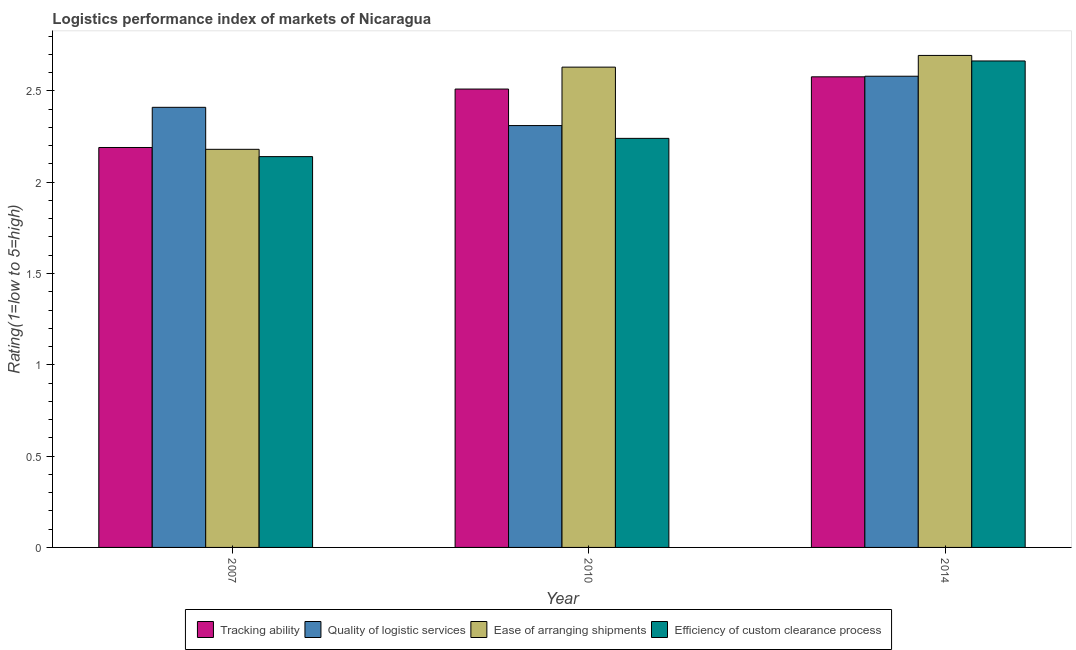How many different coloured bars are there?
Your answer should be very brief. 4. How many groups of bars are there?
Provide a succinct answer. 3. Are the number of bars per tick equal to the number of legend labels?
Keep it short and to the point. Yes. How many bars are there on the 3rd tick from the left?
Provide a short and direct response. 4. In how many cases, is the number of bars for a given year not equal to the number of legend labels?
Make the answer very short. 0. What is the lpi rating of efficiency of custom clearance process in 2014?
Offer a terse response. 2.66. Across all years, what is the maximum lpi rating of tracking ability?
Your answer should be very brief. 2.58. Across all years, what is the minimum lpi rating of tracking ability?
Your answer should be compact. 2.19. In which year was the lpi rating of quality of logistic services minimum?
Your answer should be compact. 2010. What is the total lpi rating of tracking ability in the graph?
Make the answer very short. 7.28. What is the difference between the lpi rating of tracking ability in 2007 and that in 2010?
Provide a short and direct response. -0.32. What is the difference between the lpi rating of ease of arranging shipments in 2010 and the lpi rating of quality of logistic services in 2007?
Your answer should be compact. 0.45. What is the average lpi rating of ease of arranging shipments per year?
Your answer should be compact. 2.5. In the year 2014, what is the difference between the lpi rating of ease of arranging shipments and lpi rating of efficiency of custom clearance process?
Give a very brief answer. 0. What is the ratio of the lpi rating of quality of logistic services in 2007 to that in 2010?
Ensure brevity in your answer.  1.04. Is the difference between the lpi rating of efficiency of custom clearance process in 2007 and 2010 greater than the difference between the lpi rating of ease of arranging shipments in 2007 and 2010?
Give a very brief answer. No. What is the difference between the highest and the second highest lpi rating of quality of logistic services?
Offer a terse response. 0.17. What is the difference between the highest and the lowest lpi rating of ease of arranging shipments?
Your answer should be compact. 0.51. In how many years, is the lpi rating of efficiency of custom clearance process greater than the average lpi rating of efficiency of custom clearance process taken over all years?
Offer a very short reply. 1. Is it the case that in every year, the sum of the lpi rating of tracking ability and lpi rating of quality of logistic services is greater than the sum of lpi rating of efficiency of custom clearance process and lpi rating of ease of arranging shipments?
Make the answer very short. No. What does the 2nd bar from the left in 2014 represents?
Provide a short and direct response. Quality of logistic services. What does the 4th bar from the right in 2007 represents?
Offer a very short reply. Tracking ability. What is the difference between two consecutive major ticks on the Y-axis?
Your response must be concise. 0.5. Does the graph contain grids?
Your answer should be compact. No. How many legend labels are there?
Ensure brevity in your answer.  4. What is the title of the graph?
Offer a very short reply. Logistics performance index of markets of Nicaragua. What is the label or title of the Y-axis?
Offer a terse response. Rating(1=low to 5=high). What is the Rating(1=low to 5=high) in Tracking ability in 2007?
Your answer should be compact. 2.19. What is the Rating(1=low to 5=high) of Quality of logistic services in 2007?
Provide a short and direct response. 2.41. What is the Rating(1=low to 5=high) in Ease of arranging shipments in 2007?
Offer a terse response. 2.18. What is the Rating(1=low to 5=high) in Efficiency of custom clearance process in 2007?
Give a very brief answer. 2.14. What is the Rating(1=low to 5=high) in Tracking ability in 2010?
Provide a short and direct response. 2.51. What is the Rating(1=low to 5=high) in Quality of logistic services in 2010?
Your response must be concise. 2.31. What is the Rating(1=low to 5=high) of Ease of arranging shipments in 2010?
Provide a short and direct response. 2.63. What is the Rating(1=low to 5=high) in Efficiency of custom clearance process in 2010?
Offer a terse response. 2.24. What is the Rating(1=low to 5=high) of Tracking ability in 2014?
Ensure brevity in your answer.  2.58. What is the Rating(1=low to 5=high) in Quality of logistic services in 2014?
Provide a succinct answer. 2.58. What is the Rating(1=low to 5=high) in Ease of arranging shipments in 2014?
Keep it short and to the point. 2.69. What is the Rating(1=low to 5=high) of Efficiency of custom clearance process in 2014?
Offer a very short reply. 2.66. Across all years, what is the maximum Rating(1=low to 5=high) in Tracking ability?
Make the answer very short. 2.58. Across all years, what is the maximum Rating(1=low to 5=high) of Quality of logistic services?
Your response must be concise. 2.58. Across all years, what is the maximum Rating(1=low to 5=high) in Ease of arranging shipments?
Provide a succinct answer. 2.69. Across all years, what is the maximum Rating(1=low to 5=high) in Efficiency of custom clearance process?
Provide a succinct answer. 2.66. Across all years, what is the minimum Rating(1=low to 5=high) in Tracking ability?
Make the answer very short. 2.19. Across all years, what is the minimum Rating(1=low to 5=high) of Quality of logistic services?
Offer a terse response. 2.31. Across all years, what is the minimum Rating(1=low to 5=high) in Ease of arranging shipments?
Make the answer very short. 2.18. Across all years, what is the minimum Rating(1=low to 5=high) in Efficiency of custom clearance process?
Your answer should be compact. 2.14. What is the total Rating(1=low to 5=high) in Tracking ability in the graph?
Offer a very short reply. 7.28. What is the total Rating(1=low to 5=high) of Quality of logistic services in the graph?
Provide a short and direct response. 7.3. What is the total Rating(1=low to 5=high) of Ease of arranging shipments in the graph?
Provide a short and direct response. 7.5. What is the total Rating(1=low to 5=high) of Efficiency of custom clearance process in the graph?
Provide a short and direct response. 7.04. What is the difference between the Rating(1=low to 5=high) of Tracking ability in 2007 and that in 2010?
Provide a succinct answer. -0.32. What is the difference between the Rating(1=low to 5=high) in Quality of logistic services in 2007 and that in 2010?
Your response must be concise. 0.1. What is the difference between the Rating(1=low to 5=high) of Ease of arranging shipments in 2007 and that in 2010?
Make the answer very short. -0.45. What is the difference between the Rating(1=low to 5=high) in Efficiency of custom clearance process in 2007 and that in 2010?
Make the answer very short. -0.1. What is the difference between the Rating(1=low to 5=high) in Tracking ability in 2007 and that in 2014?
Your response must be concise. -0.39. What is the difference between the Rating(1=low to 5=high) in Quality of logistic services in 2007 and that in 2014?
Provide a succinct answer. -0.17. What is the difference between the Rating(1=low to 5=high) in Ease of arranging shipments in 2007 and that in 2014?
Offer a very short reply. -0.51. What is the difference between the Rating(1=low to 5=high) of Efficiency of custom clearance process in 2007 and that in 2014?
Offer a terse response. -0.52. What is the difference between the Rating(1=low to 5=high) in Tracking ability in 2010 and that in 2014?
Give a very brief answer. -0.07. What is the difference between the Rating(1=low to 5=high) of Quality of logistic services in 2010 and that in 2014?
Offer a terse response. -0.27. What is the difference between the Rating(1=low to 5=high) in Ease of arranging shipments in 2010 and that in 2014?
Make the answer very short. -0.06. What is the difference between the Rating(1=low to 5=high) of Efficiency of custom clearance process in 2010 and that in 2014?
Make the answer very short. -0.42. What is the difference between the Rating(1=low to 5=high) in Tracking ability in 2007 and the Rating(1=low to 5=high) in Quality of logistic services in 2010?
Offer a very short reply. -0.12. What is the difference between the Rating(1=low to 5=high) of Tracking ability in 2007 and the Rating(1=low to 5=high) of Ease of arranging shipments in 2010?
Your answer should be compact. -0.44. What is the difference between the Rating(1=low to 5=high) of Quality of logistic services in 2007 and the Rating(1=low to 5=high) of Ease of arranging shipments in 2010?
Your answer should be compact. -0.22. What is the difference between the Rating(1=low to 5=high) of Quality of logistic services in 2007 and the Rating(1=low to 5=high) of Efficiency of custom clearance process in 2010?
Your answer should be compact. 0.17. What is the difference between the Rating(1=low to 5=high) in Ease of arranging shipments in 2007 and the Rating(1=low to 5=high) in Efficiency of custom clearance process in 2010?
Your answer should be very brief. -0.06. What is the difference between the Rating(1=low to 5=high) of Tracking ability in 2007 and the Rating(1=low to 5=high) of Quality of logistic services in 2014?
Your answer should be compact. -0.39. What is the difference between the Rating(1=low to 5=high) of Tracking ability in 2007 and the Rating(1=low to 5=high) of Ease of arranging shipments in 2014?
Your response must be concise. -0.5. What is the difference between the Rating(1=low to 5=high) in Tracking ability in 2007 and the Rating(1=low to 5=high) in Efficiency of custom clearance process in 2014?
Make the answer very short. -0.47. What is the difference between the Rating(1=low to 5=high) of Quality of logistic services in 2007 and the Rating(1=low to 5=high) of Ease of arranging shipments in 2014?
Offer a very short reply. -0.28. What is the difference between the Rating(1=low to 5=high) in Quality of logistic services in 2007 and the Rating(1=low to 5=high) in Efficiency of custom clearance process in 2014?
Provide a succinct answer. -0.25. What is the difference between the Rating(1=low to 5=high) in Ease of arranging shipments in 2007 and the Rating(1=low to 5=high) in Efficiency of custom clearance process in 2014?
Ensure brevity in your answer.  -0.48. What is the difference between the Rating(1=low to 5=high) of Tracking ability in 2010 and the Rating(1=low to 5=high) of Quality of logistic services in 2014?
Offer a terse response. -0.07. What is the difference between the Rating(1=low to 5=high) of Tracking ability in 2010 and the Rating(1=low to 5=high) of Ease of arranging shipments in 2014?
Ensure brevity in your answer.  -0.18. What is the difference between the Rating(1=low to 5=high) in Tracking ability in 2010 and the Rating(1=low to 5=high) in Efficiency of custom clearance process in 2014?
Your response must be concise. -0.15. What is the difference between the Rating(1=low to 5=high) in Quality of logistic services in 2010 and the Rating(1=low to 5=high) in Ease of arranging shipments in 2014?
Offer a very short reply. -0.38. What is the difference between the Rating(1=low to 5=high) of Quality of logistic services in 2010 and the Rating(1=low to 5=high) of Efficiency of custom clearance process in 2014?
Offer a very short reply. -0.35. What is the difference between the Rating(1=low to 5=high) in Ease of arranging shipments in 2010 and the Rating(1=low to 5=high) in Efficiency of custom clearance process in 2014?
Your answer should be very brief. -0.03. What is the average Rating(1=low to 5=high) in Tracking ability per year?
Keep it short and to the point. 2.43. What is the average Rating(1=low to 5=high) in Quality of logistic services per year?
Provide a succinct answer. 2.43. What is the average Rating(1=low to 5=high) in Ease of arranging shipments per year?
Your answer should be compact. 2.5. What is the average Rating(1=low to 5=high) in Efficiency of custom clearance process per year?
Provide a short and direct response. 2.35. In the year 2007, what is the difference between the Rating(1=low to 5=high) of Tracking ability and Rating(1=low to 5=high) of Quality of logistic services?
Your answer should be very brief. -0.22. In the year 2007, what is the difference between the Rating(1=low to 5=high) in Quality of logistic services and Rating(1=low to 5=high) in Ease of arranging shipments?
Keep it short and to the point. 0.23. In the year 2007, what is the difference between the Rating(1=low to 5=high) in Quality of logistic services and Rating(1=low to 5=high) in Efficiency of custom clearance process?
Make the answer very short. 0.27. In the year 2007, what is the difference between the Rating(1=low to 5=high) of Ease of arranging shipments and Rating(1=low to 5=high) of Efficiency of custom clearance process?
Make the answer very short. 0.04. In the year 2010, what is the difference between the Rating(1=low to 5=high) in Tracking ability and Rating(1=low to 5=high) in Quality of logistic services?
Give a very brief answer. 0.2. In the year 2010, what is the difference between the Rating(1=low to 5=high) in Tracking ability and Rating(1=low to 5=high) in Ease of arranging shipments?
Offer a very short reply. -0.12. In the year 2010, what is the difference between the Rating(1=low to 5=high) in Tracking ability and Rating(1=low to 5=high) in Efficiency of custom clearance process?
Provide a succinct answer. 0.27. In the year 2010, what is the difference between the Rating(1=low to 5=high) in Quality of logistic services and Rating(1=low to 5=high) in Ease of arranging shipments?
Offer a very short reply. -0.32. In the year 2010, what is the difference between the Rating(1=low to 5=high) in Quality of logistic services and Rating(1=low to 5=high) in Efficiency of custom clearance process?
Keep it short and to the point. 0.07. In the year 2010, what is the difference between the Rating(1=low to 5=high) in Ease of arranging shipments and Rating(1=low to 5=high) in Efficiency of custom clearance process?
Give a very brief answer. 0.39. In the year 2014, what is the difference between the Rating(1=low to 5=high) of Tracking ability and Rating(1=low to 5=high) of Quality of logistic services?
Give a very brief answer. -0. In the year 2014, what is the difference between the Rating(1=low to 5=high) in Tracking ability and Rating(1=low to 5=high) in Ease of arranging shipments?
Provide a short and direct response. -0.12. In the year 2014, what is the difference between the Rating(1=low to 5=high) of Tracking ability and Rating(1=low to 5=high) of Efficiency of custom clearance process?
Ensure brevity in your answer.  -0.09. In the year 2014, what is the difference between the Rating(1=low to 5=high) in Quality of logistic services and Rating(1=low to 5=high) in Ease of arranging shipments?
Keep it short and to the point. -0.11. In the year 2014, what is the difference between the Rating(1=low to 5=high) in Quality of logistic services and Rating(1=low to 5=high) in Efficiency of custom clearance process?
Give a very brief answer. -0.08. In the year 2014, what is the difference between the Rating(1=low to 5=high) in Ease of arranging shipments and Rating(1=low to 5=high) in Efficiency of custom clearance process?
Offer a very short reply. 0.03. What is the ratio of the Rating(1=low to 5=high) of Tracking ability in 2007 to that in 2010?
Provide a succinct answer. 0.87. What is the ratio of the Rating(1=low to 5=high) of Quality of logistic services in 2007 to that in 2010?
Your answer should be very brief. 1.04. What is the ratio of the Rating(1=low to 5=high) in Ease of arranging shipments in 2007 to that in 2010?
Offer a terse response. 0.83. What is the ratio of the Rating(1=low to 5=high) in Efficiency of custom clearance process in 2007 to that in 2010?
Provide a succinct answer. 0.96. What is the ratio of the Rating(1=low to 5=high) of Tracking ability in 2007 to that in 2014?
Give a very brief answer. 0.85. What is the ratio of the Rating(1=low to 5=high) of Quality of logistic services in 2007 to that in 2014?
Provide a succinct answer. 0.93. What is the ratio of the Rating(1=low to 5=high) of Ease of arranging shipments in 2007 to that in 2014?
Provide a succinct answer. 0.81. What is the ratio of the Rating(1=low to 5=high) of Efficiency of custom clearance process in 2007 to that in 2014?
Your response must be concise. 0.8. What is the ratio of the Rating(1=low to 5=high) in Tracking ability in 2010 to that in 2014?
Your answer should be compact. 0.97. What is the ratio of the Rating(1=low to 5=high) of Quality of logistic services in 2010 to that in 2014?
Make the answer very short. 0.9. What is the ratio of the Rating(1=low to 5=high) in Ease of arranging shipments in 2010 to that in 2014?
Your answer should be very brief. 0.98. What is the ratio of the Rating(1=low to 5=high) in Efficiency of custom clearance process in 2010 to that in 2014?
Your answer should be very brief. 0.84. What is the difference between the highest and the second highest Rating(1=low to 5=high) in Tracking ability?
Provide a succinct answer. 0.07. What is the difference between the highest and the second highest Rating(1=low to 5=high) in Quality of logistic services?
Your answer should be compact. 0.17. What is the difference between the highest and the second highest Rating(1=low to 5=high) in Ease of arranging shipments?
Ensure brevity in your answer.  0.06. What is the difference between the highest and the second highest Rating(1=low to 5=high) of Efficiency of custom clearance process?
Make the answer very short. 0.42. What is the difference between the highest and the lowest Rating(1=low to 5=high) of Tracking ability?
Provide a short and direct response. 0.39. What is the difference between the highest and the lowest Rating(1=low to 5=high) in Quality of logistic services?
Your response must be concise. 0.27. What is the difference between the highest and the lowest Rating(1=low to 5=high) of Ease of arranging shipments?
Your response must be concise. 0.51. What is the difference between the highest and the lowest Rating(1=low to 5=high) in Efficiency of custom clearance process?
Make the answer very short. 0.52. 